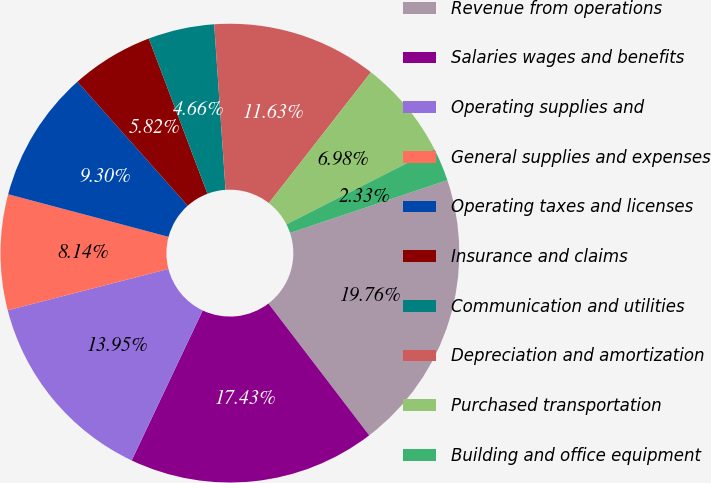Convert chart to OTSL. <chart><loc_0><loc_0><loc_500><loc_500><pie_chart><fcel>Revenue from operations<fcel>Salaries wages and benefits<fcel>Operating supplies and<fcel>General supplies and expenses<fcel>Operating taxes and licenses<fcel>Insurance and claims<fcel>Communication and utilities<fcel>Depreciation and amortization<fcel>Purchased transportation<fcel>Building and office equipment<nl><fcel>19.76%<fcel>17.43%<fcel>13.95%<fcel>8.14%<fcel>9.3%<fcel>5.82%<fcel>4.66%<fcel>11.63%<fcel>6.98%<fcel>2.33%<nl></chart> 